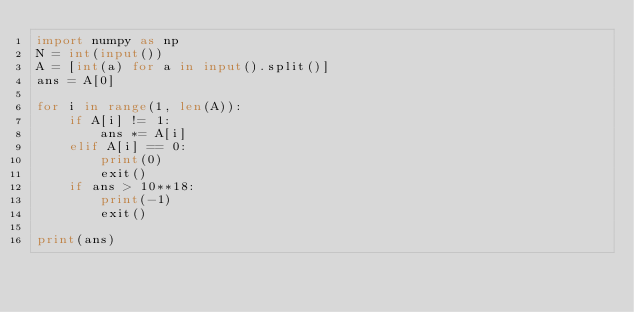<code> <loc_0><loc_0><loc_500><loc_500><_Python_>import numpy as np
N = int(input())
A = [int(a) for a in input().split()]
ans = A[0]

for i in range(1, len(A)):
    if A[i] != 1:
        ans *= A[i]
    elif A[i] == 0:
        print(0)
        exit()
    if ans > 10**18:
        print(-1)
        exit()

print(ans)</code> 